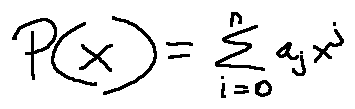Convert formula to latex. <formula><loc_0><loc_0><loc_500><loc_500>P ( x ) = \sum \lim i t s _ { i = 0 } ^ { n } a _ { j } x ^ { j }</formula> 